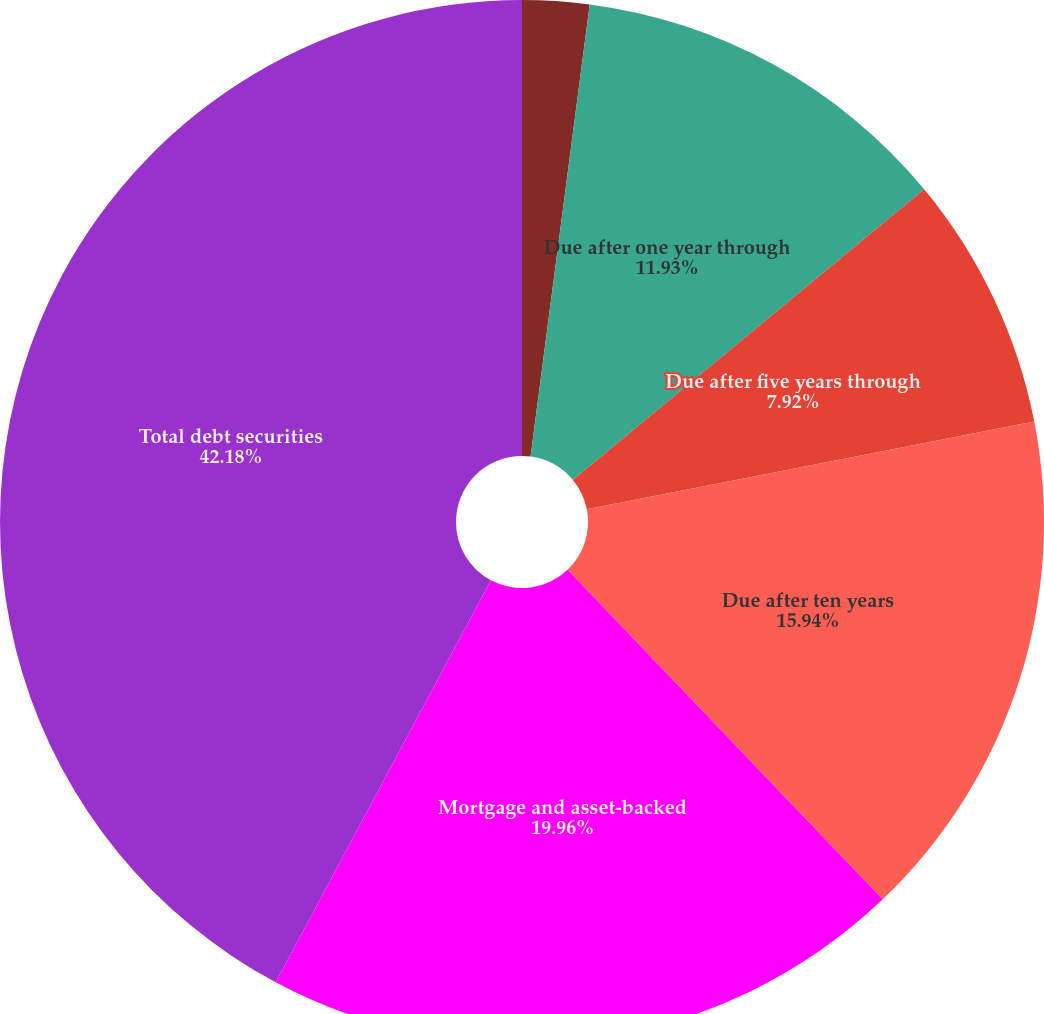Convert chart to OTSL. <chart><loc_0><loc_0><loc_500><loc_500><pie_chart><fcel>Due within one year<fcel>Due after one year through<fcel>Due after five years through<fcel>Due after ten years<fcel>Mortgage and asset-backed<fcel>Total debt securities<nl><fcel>2.07%<fcel>11.93%<fcel>7.92%<fcel>15.94%<fcel>19.96%<fcel>42.18%<nl></chart> 